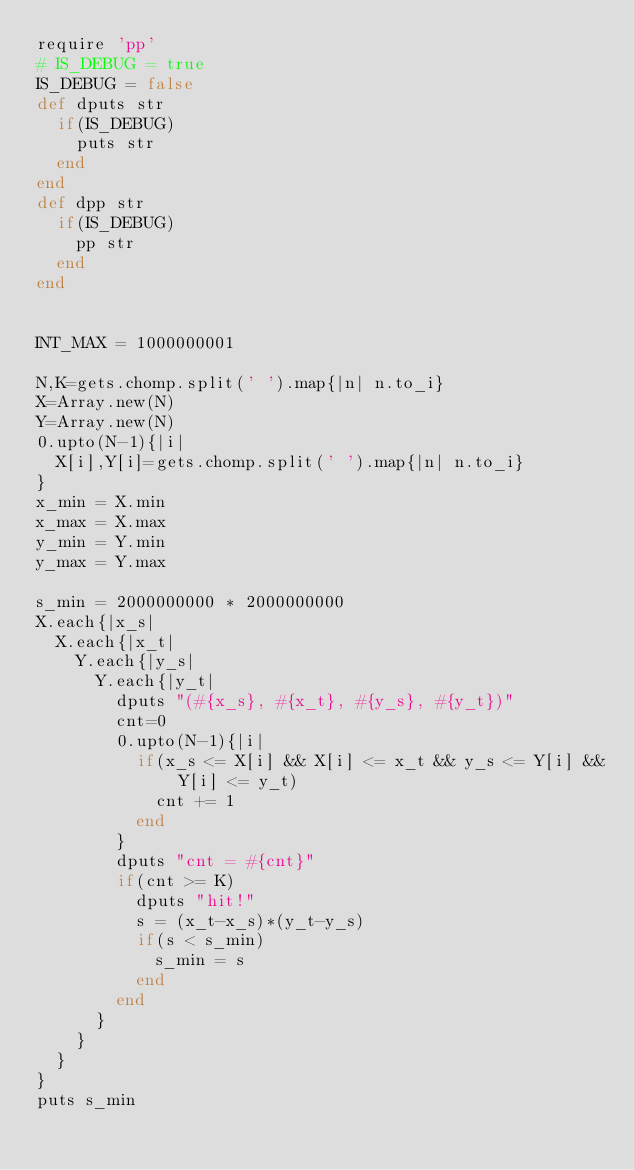Convert code to text. <code><loc_0><loc_0><loc_500><loc_500><_Ruby_>require 'pp'
# IS_DEBUG = true
IS_DEBUG = false
def dputs str
	if(IS_DEBUG)
		puts str
	end
end
def dpp str
	if(IS_DEBUG)
		pp str
	end
end


INT_MAX = 1000000001

N,K=gets.chomp.split(' ').map{|n| n.to_i}
X=Array.new(N)
Y=Array.new(N)
0.upto(N-1){|i|
	X[i],Y[i]=gets.chomp.split(' ').map{|n| n.to_i}
}
x_min = X.min
x_max = X.max
y_min = Y.min
y_max = Y.max

s_min = 2000000000 * 2000000000 
X.each{|x_s|
	X.each{|x_t|
		Y.each{|y_s|
			Y.each{|y_t|
				dputs "(#{x_s}, #{x_t}, #{y_s}, #{y_t})"
				cnt=0
				0.upto(N-1){|i|
					if(x_s <= X[i] && X[i] <= x_t && y_s <= Y[i] && Y[i] <= y_t)
						cnt += 1
					end
				}
				dputs "cnt = #{cnt}"
				if(cnt >= K)
					dputs "hit!"
					s = (x_t-x_s)*(y_t-y_s)
					if(s < s_min)
						s_min = s
					end
				end
			}
		}
	}
}
puts s_min

</code> 